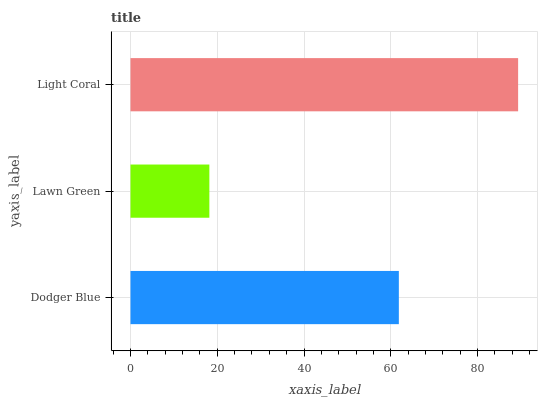Is Lawn Green the minimum?
Answer yes or no. Yes. Is Light Coral the maximum?
Answer yes or no. Yes. Is Light Coral the minimum?
Answer yes or no. No. Is Lawn Green the maximum?
Answer yes or no. No. Is Light Coral greater than Lawn Green?
Answer yes or no. Yes. Is Lawn Green less than Light Coral?
Answer yes or no. Yes. Is Lawn Green greater than Light Coral?
Answer yes or no. No. Is Light Coral less than Lawn Green?
Answer yes or no. No. Is Dodger Blue the high median?
Answer yes or no. Yes. Is Dodger Blue the low median?
Answer yes or no. Yes. Is Light Coral the high median?
Answer yes or no. No. Is Lawn Green the low median?
Answer yes or no. No. 